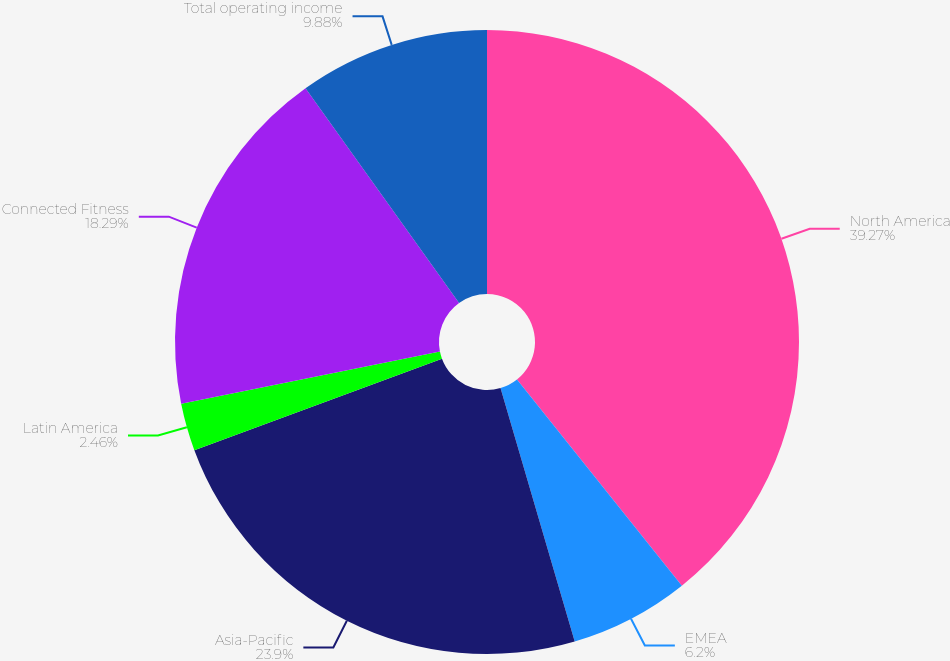Convert chart to OTSL. <chart><loc_0><loc_0><loc_500><loc_500><pie_chart><fcel>North America<fcel>EMEA<fcel>Asia-Pacific<fcel>Latin America<fcel>Connected Fitness<fcel>Total operating income<nl><fcel>39.26%<fcel>6.2%<fcel>23.9%<fcel>2.46%<fcel>18.29%<fcel>9.88%<nl></chart> 